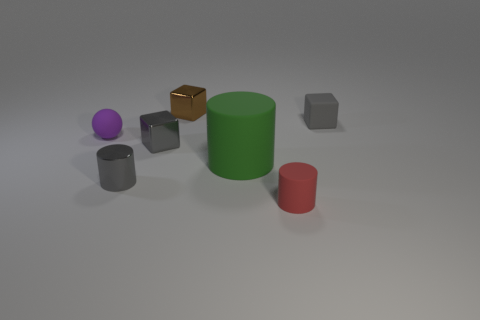There is a cube that is in front of the tiny sphere; does it have the same color as the tiny rubber cube?
Offer a very short reply. Yes. Is there anything else that is the same size as the green object?
Ensure brevity in your answer.  No. There is a cylinder right of the green rubber thing; are there any matte cylinders that are to the right of it?
Keep it short and to the point. No. There is a tiny rubber thing that is left of the gray shiny cylinder; is its shape the same as the small red object?
Provide a succinct answer. No. What is the shape of the small red matte thing?
Offer a very short reply. Cylinder. What number of big cylinders are the same material as the sphere?
Your response must be concise. 1. There is a matte cube; does it have the same color as the block that is in front of the matte sphere?
Offer a very short reply. Yes. How many gray shiny objects are there?
Make the answer very short. 2. Are there any tiny objects of the same color as the metallic cylinder?
Your answer should be very brief. Yes. There is a cube that is right of the small cylinder that is right of the small cylinder left of the green cylinder; what is its color?
Provide a short and direct response. Gray. 